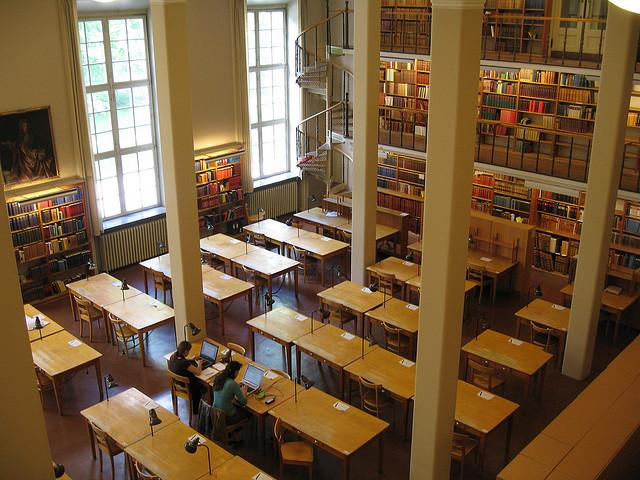What is located in the corner? spiral staircase 